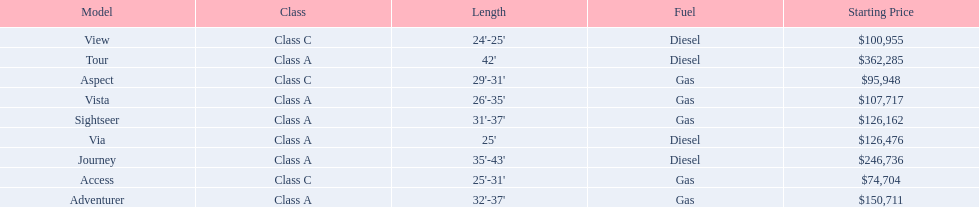What are the prices? $362,285, $246,736, $150,711, $126,476, $126,162, $107,717, $100,955, $95,948, $74,704. What is the top price? $362,285. What model has this price? Tour. 